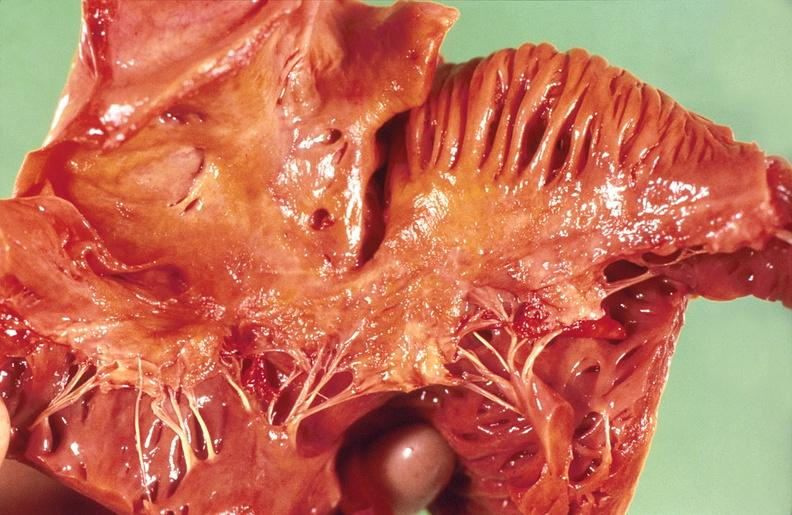does chest and abdomen slide show amyloidosis?
Answer the question using a single word or phrase. No 